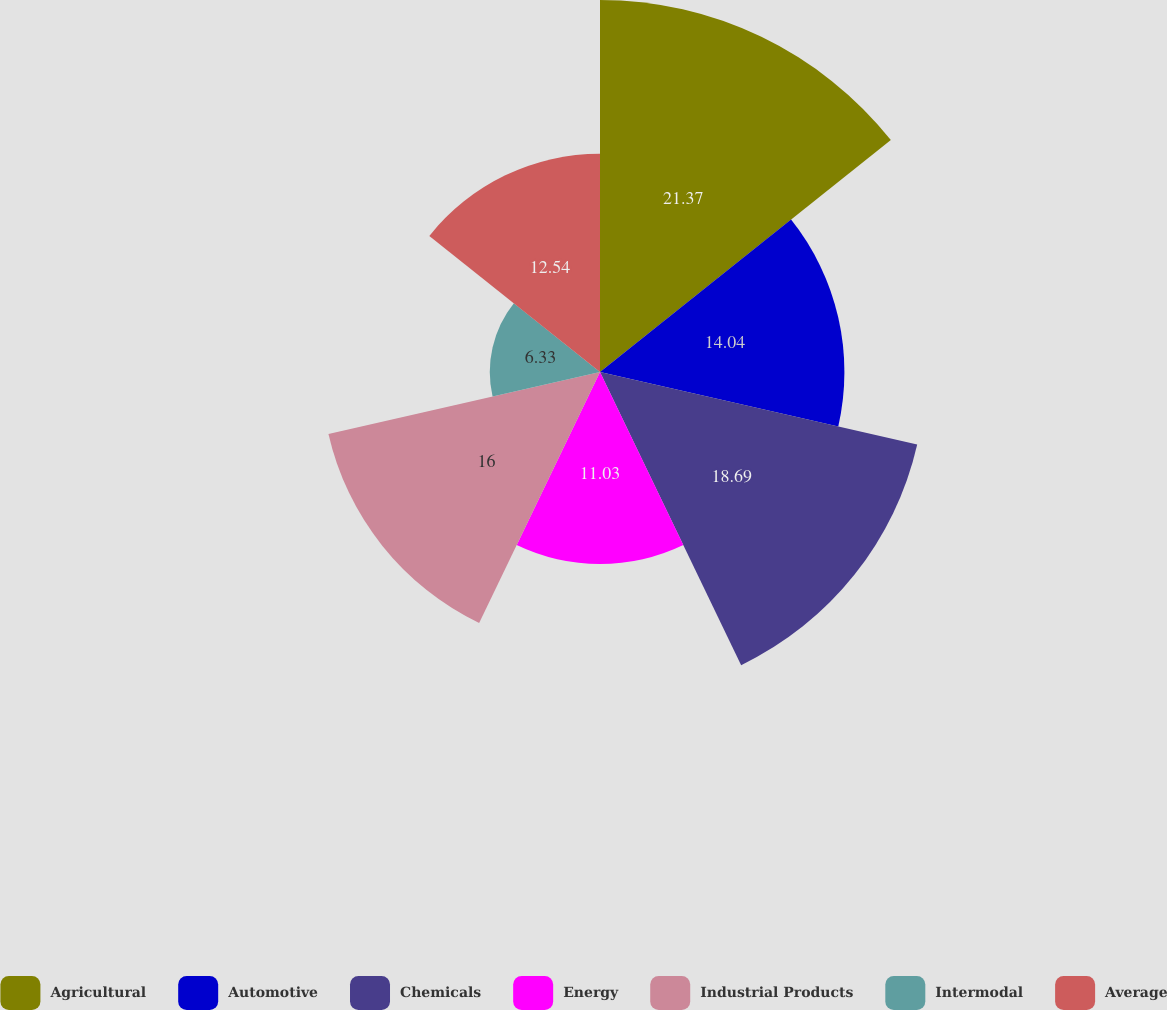Convert chart. <chart><loc_0><loc_0><loc_500><loc_500><pie_chart><fcel>Agricultural<fcel>Automotive<fcel>Chemicals<fcel>Energy<fcel>Industrial Products<fcel>Intermodal<fcel>Average<nl><fcel>21.37%<fcel>14.04%<fcel>18.69%<fcel>11.03%<fcel>16.0%<fcel>6.33%<fcel>12.54%<nl></chart> 